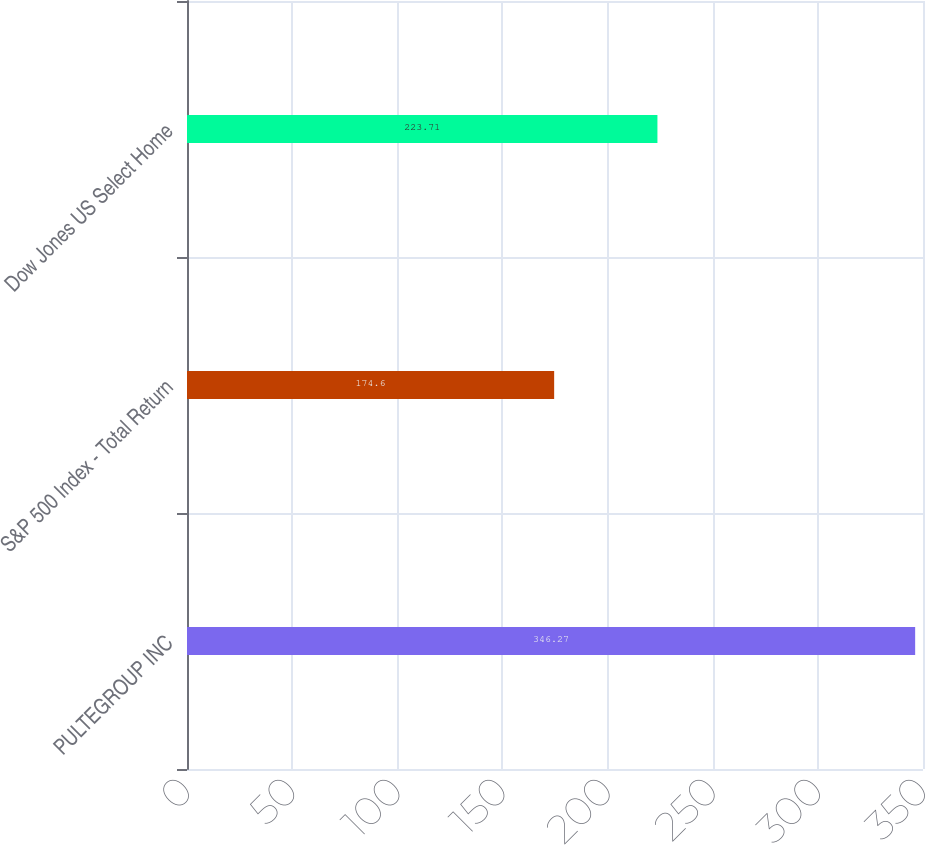Convert chart. <chart><loc_0><loc_0><loc_500><loc_500><bar_chart><fcel>PULTEGROUP INC<fcel>S&P 500 Index - Total Return<fcel>Dow Jones US Select Home<nl><fcel>346.27<fcel>174.6<fcel>223.71<nl></chart> 